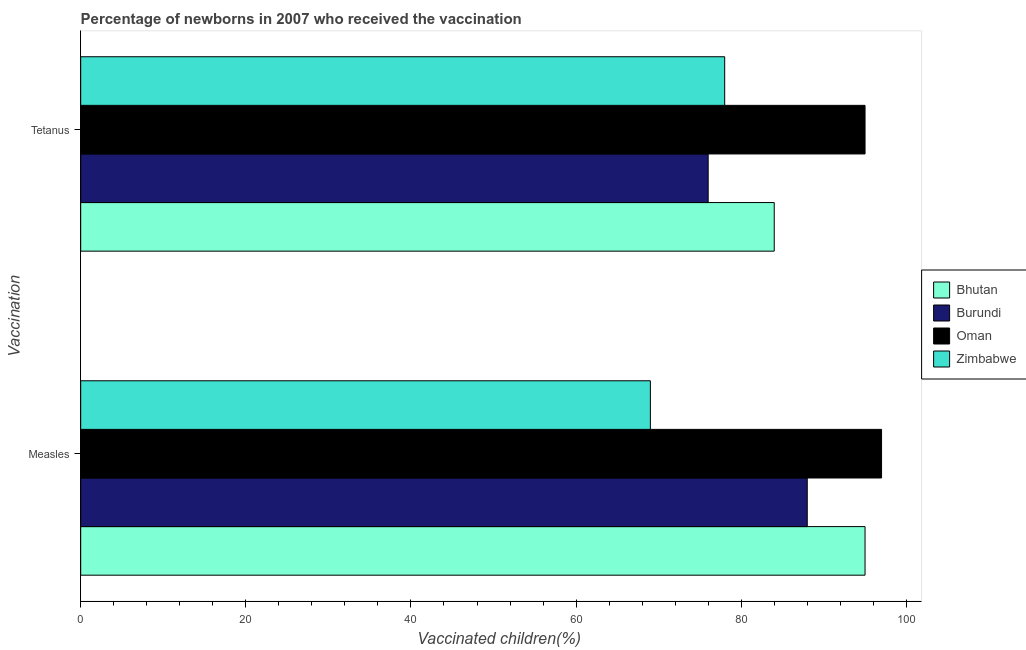How many groups of bars are there?
Provide a short and direct response. 2. Are the number of bars per tick equal to the number of legend labels?
Offer a terse response. Yes. Are the number of bars on each tick of the Y-axis equal?
Give a very brief answer. Yes. How many bars are there on the 1st tick from the bottom?
Provide a short and direct response. 4. What is the label of the 1st group of bars from the top?
Your response must be concise. Tetanus. What is the percentage of newborns who received vaccination for tetanus in Bhutan?
Give a very brief answer. 84. Across all countries, what is the maximum percentage of newborns who received vaccination for measles?
Make the answer very short. 97. Across all countries, what is the minimum percentage of newborns who received vaccination for tetanus?
Provide a short and direct response. 76. In which country was the percentage of newborns who received vaccination for tetanus maximum?
Your response must be concise. Oman. In which country was the percentage of newborns who received vaccination for measles minimum?
Provide a succinct answer. Zimbabwe. What is the total percentage of newborns who received vaccination for tetanus in the graph?
Give a very brief answer. 333. What is the difference between the percentage of newborns who received vaccination for measles in Oman and that in Zimbabwe?
Offer a very short reply. 28. What is the difference between the percentage of newborns who received vaccination for measles in Oman and the percentage of newborns who received vaccination for tetanus in Bhutan?
Provide a succinct answer. 13. What is the average percentage of newborns who received vaccination for measles per country?
Provide a short and direct response. 87.25. What is the difference between the percentage of newborns who received vaccination for measles and percentage of newborns who received vaccination for tetanus in Burundi?
Provide a short and direct response. 12. In how many countries, is the percentage of newborns who received vaccination for measles greater than 80 %?
Give a very brief answer. 3. What is the ratio of the percentage of newborns who received vaccination for tetanus in Burundi to that in Bhutan?
Ensure brevity in your answer.  0.9. What does the 1st bar from the top in Measles represents?
Keep it short and to the point. Zimbabwe. What does the 1st bar from the bottom in Measles represents?
Your answer should be compact. Bhutan. Are all the bars in the graph horizontal?
Your response must be concise. Yes. How many countries are there in the graph?
Your answer should be very brief. 4. Does the graph contain any zero values?
Keep it short and to the point. No. Does the graph contain grids?
Give a very brief answer. No. Where does the legend appear in the graph?
Keep it short and to the point. Center right. How many legend labels are there?
Give a very brief answer. 4. What is the title of the graph?
Your answer should be compact. Percentage of newborns in 2007 who received the vaccination. What is the label or title of the X-axis?
Keep it short and to the point. Vaccinated children(%)
. What is the label or title of the Y-axis?
Offer a very short reply. Vaccination. What is the Vaccinated children(%)
 in Bhutan in Measles?
Your answer should be very brief. 95. What is the Vaccinated children(%)
 in Burundi in Measles?
Your answer should be very brief. 88. What is the Vaccinated children(%)
 in Oman in Measles?
Provide a succinct answer. 97. What is the Vaccinated children(%)
 in Zimbabwe in Measles?
Offer a very short reply. 69. What is the Vaccinated children(%)
 in Burundi in Tetanus?
Provide a succinct answer. 76. Across all Vaccination, what is the maximum Vaccinated children(%)
 in Bhutan?
Your response must be concise. 95. Across all Vaccination, what is the maximum Vaccinated children(%)
 in Oman?
Provide a short and direct response. 97. Across all Vaccination, what is the maximum Vaccinated children(%)
 of Zimbabwe?
Provide a succinct answer. 78. Across all Vaccination, what is the minimum Vaccinated children(%)
 in Bhutan?
Make the answer very short. 84. Across all Vaccination, what is the minimum Vaccinated children(%)
 in Burundi?
Provide a succinct answer. 76. What is the total Vaccinated children(%)
 in Bhutan in the graph?
Offer a very short reply. 179. What is the total Vaccinated children(%)
 in Burundi in the graph?
Make the answer very short. 164. What is the total Vaccinated children(%)
 in Oman in the graph?
Provide a succinct answer. 192. What is the total Vaccinated children(%)
 in Zimbabwe in the graph?
Provide a short and direct response. 147. What is the difference between the Vaccinated children(%)
 of Bhutan in Measles and the Vaccinated children(%)
 of Burundi in Tetanus?
Make the answer very short. 19. What is the difference between the Vaccinated children(%)
 in Bhutan in Measles and the Vaccinated children(%)
 in Oman in Tetanus?
Your answer should be very brief. 0. What is the difference between the Vaccinated children(%)
 of Bhutan in Measles and the Vaccinated children(%)
 of Zimbabwe in Tetanus?
Give a very brief answer. 17. What is the difference between the Vaccinated children(%)
 of Burundi in Measles and the Vaccinated children(%)
 of Zimbabwe in Tetanus?
Your response must be concise. 10. What is the average Vaccinated children(%)
 of Bhutan per Vaccination?
Make the answer very short. 89.5. What is the average Vaccinated children(%)
 in Burundi per Vaccination?
Your answer should be compact. 82. What is the average Vaccinated children(%)
 of Oman per Vaccination?
Offer a very short reply. 96. What is the average Vaccinated children(%)
 in Zimbabwe per Vaccination?
Provide a short and direct response. 73.5. What is the difference between the Vaccinated children(%)
 of Burundi and Vaccinated children(%)
 of Oman in Measles?
Your answer should be very brief. -9. What is the difference between the Vaccinated children(%)
 in Bhutan and Vaccinated children(%)
 in Zimbabwe in Tetanus?
Give a very brief answer. 6. What is the difference between the Vaccinated children(%)
 in Burundi and Vaccinated children(%)
 in Oman in Tetanus?
Keep it short and to the point. -19. What is the ratio of the Vaccinated children(%)
 of Bhutan in Measles to that in Tetanus?
Provide a succinct answer. 1.13. What is the ratio of the Vaccinated children(%)
 of Burundi in Measles to that in Tetanus?
Provide a short and direct response. 1.16. What is the ratio of the Vaccinated children(%)
 of Oman in Measles to that in Tetanus?
Provide a short and direct response. 1.02. What is the ratio of the Vaccinated children(%)
 in Zimbabwe in Measles to that in Tetanus?
Give a very brief answer. 0.88. What is the difference between the highest and the second highest Vaccinated children(%)
 in Burundi?
Provide a succinct answer. 12. What is the difference between the highest and the lowest Vaccinated children(%)
 in Burundi?
Provide a short and direct response. 12. 